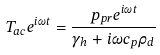<formula> <loc_0><loc_0><loc_500><loc_500>T _ { a c } e ^ { i \omega t } = \frac { p _ { p r } e ^ { i \omega t } } { \gamma _ { h } + i \omega c _ { p } \rho _ { d } }</formula> 